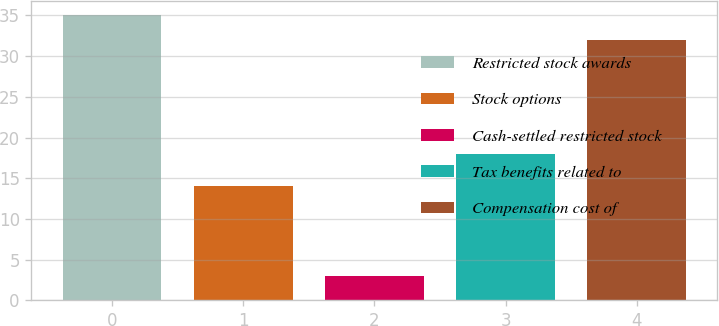<chart> <loc_0><loc_0><loc_500><loc_500><bar_chart><fcel>Restricted stock awards<fcel>Stock options<fcel>Cash-settled restricted stock<fcel>Tax benefits related to<fcel>Compensation cost of<nl><fcel>35<fcel>14<fcel>3<fcel>18<fcel>32<nl></chart> 